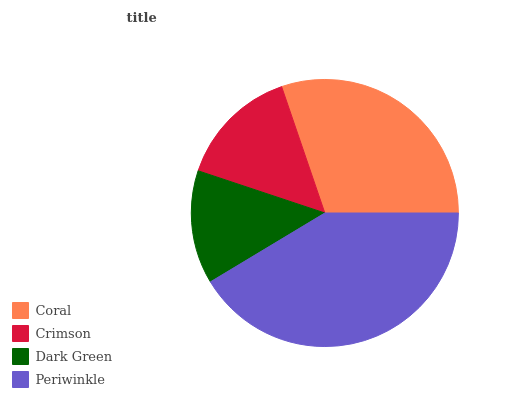Is Dark Green the minimum?
Answer yes or no. Yes. Is Periwinkle the maximum?
Answer yes or no. Yes. Is Crimson the minimum?
Answer yes or no. No. Is Crimson the maximum?
Answer yes or no. No. Is Coral greater than Crimson?
Answer yes or no. Yes. Is Crimson less than Coral?
Answer yes or no. Yes. Is Crimson greater than Coral?
Answer yes or no. No. Is Coral less than Crimson?
Answer yes or no. No. Is Coral the high median?
Answer yes or no. Yes. Is Crimson the low median?
Answer yes or no. Yes. Is Dark Green the high median?
Answer yes or no. No. Is Dark Green the low median?
Answer yes or no. No. 